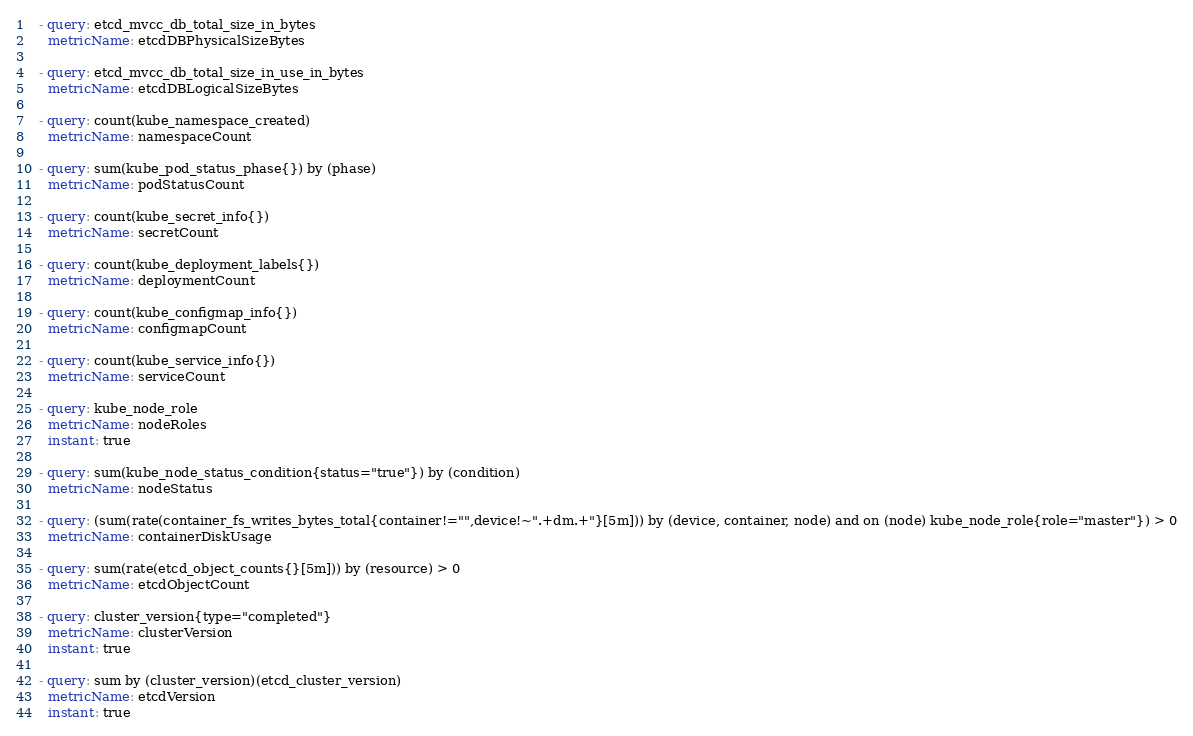Convert code to text. <code><loc_0><loc_0><loc_500><loc_500><_YAML_>  - query: etcd_mvcc_db_total_size_in_bytes
    metricName: etcdDBPhysicalSizeBytes

  - query: etcd_mvcc_db_total_size_in_use_in_bytes
    metricName: etcdDBLogicalSizeBytes

  - query: count(kube_namespace_created)
    metricName: namespaceCount

  - query: sum(kube_pod_status_phase{}) by (phase)
    metricName: podStatusCount

  - query: count(kube_secret_info{})
    metricName: secretCount

  - query: count(kube_deployment_labels{})
    metricName: deploymentCount

  - query: count(kube_configmap_info{})
    metricName: configmapCount

  - query: count(kube_service_info{})
    metricName: serviceCount

  - query: kube_node_role
    metricName: nodeRoles
    instant: true

  - query: sum(kube_node_status_condition{status="true"}) by (condition)
    metricName: nodeStatus

  - query: (sum(rate(container_fs_writes_bytes_total{container!="",device!~".+dm.+"}[5m])) by (device, container, node) and on (node) kube_node_role{role="master"}) > 0
    metricName: containerDiskUsage

  - query: sum(rate(etcd_object_counts{}[5m])) by (resource) > 0
    metricName: etcdObjectCount

  - query: cluster_version{type="completed"}
    metricName: clusterVersion
    instant: true

  - query: sum by (cluster_version)(etcd_cluster_version)
    metricName: etcdVersion
    instant: true
</code> 